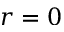Convert formula to latex. <formula><loc_0><loc_0><loc_500><loc_500>r = 0</formula> 